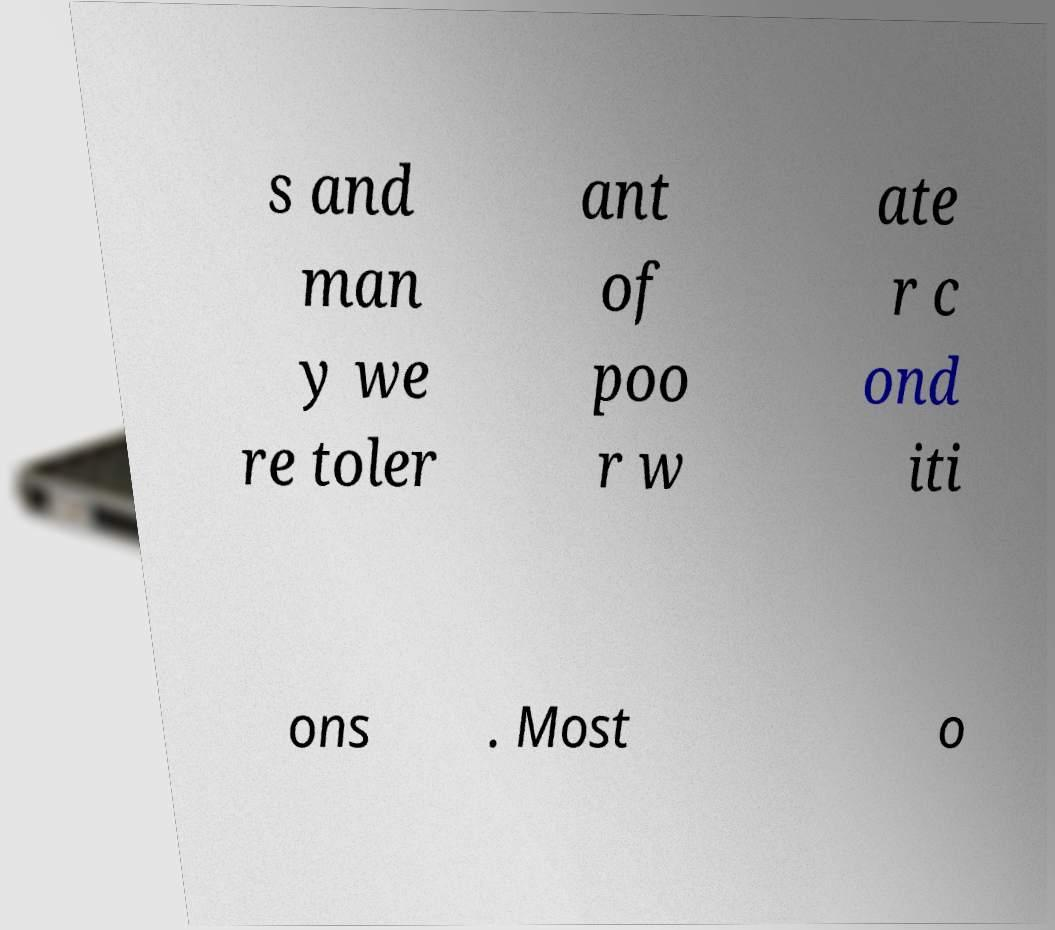There's text embedded in this image that I need extracted. Can you transcribe it verbatim? s and man y we re toler ant of poo r w ate r c ond iti ons . Most o 